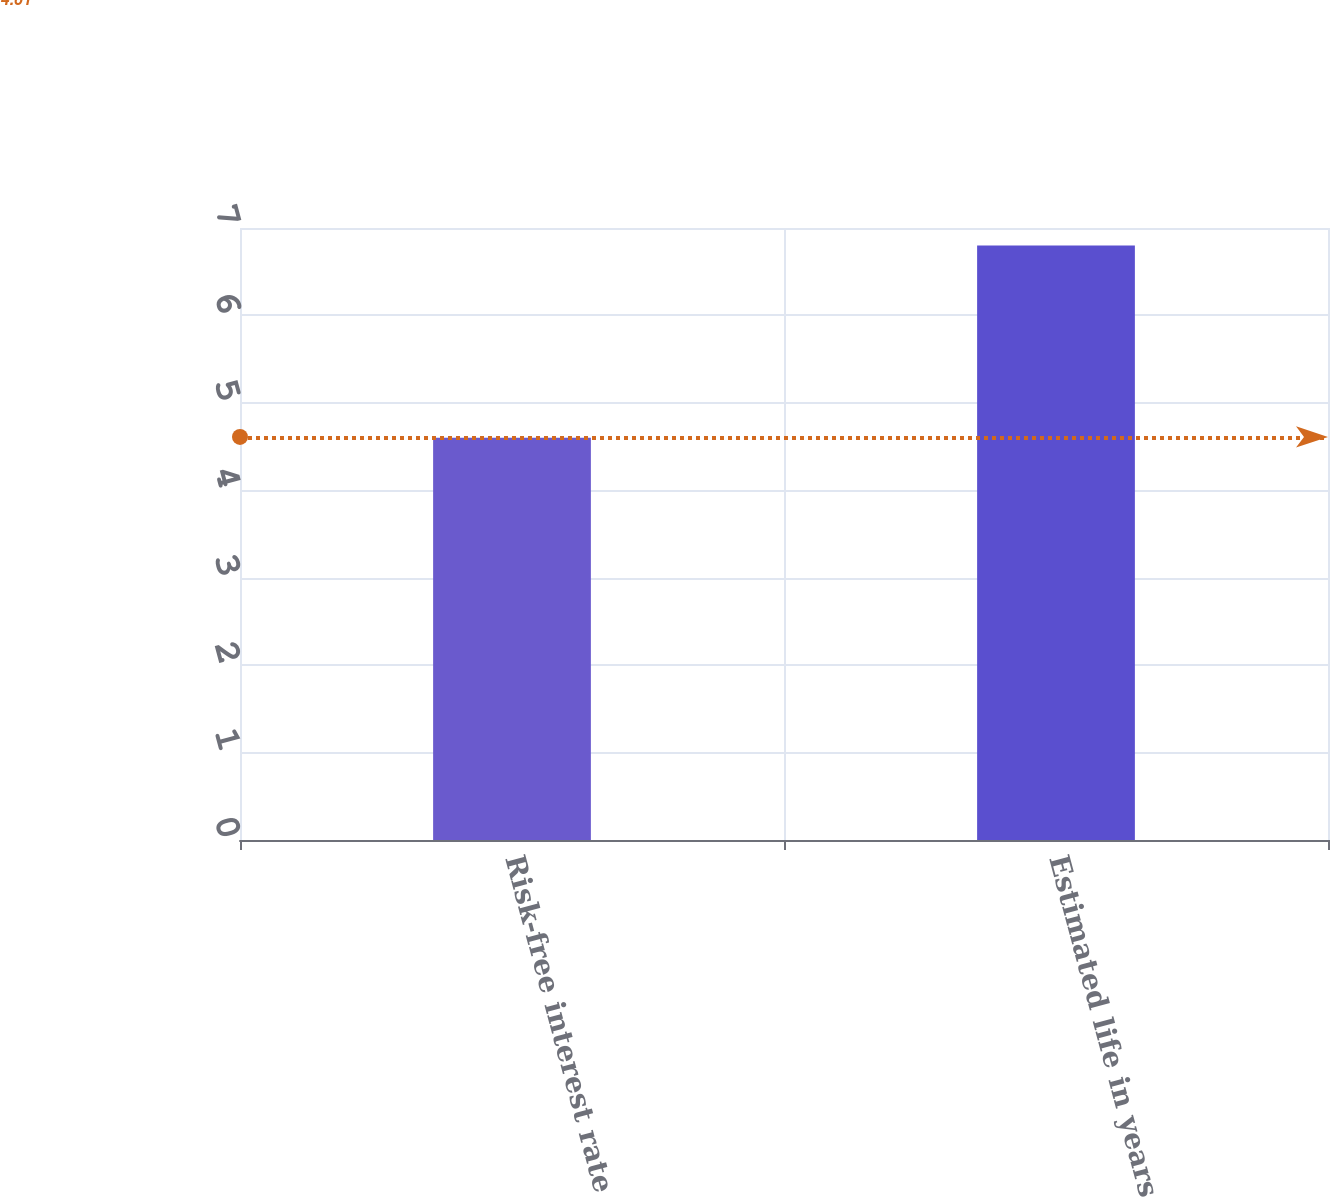Convert chart to OTSL. <chart><loc_0><loc_0><loc_500><loc_500><bar_chart><fcel>Risk-free interest rate<fcel>Estimated life in years<nl><fcel>4.6<fcel>6.8<nl></chart> 